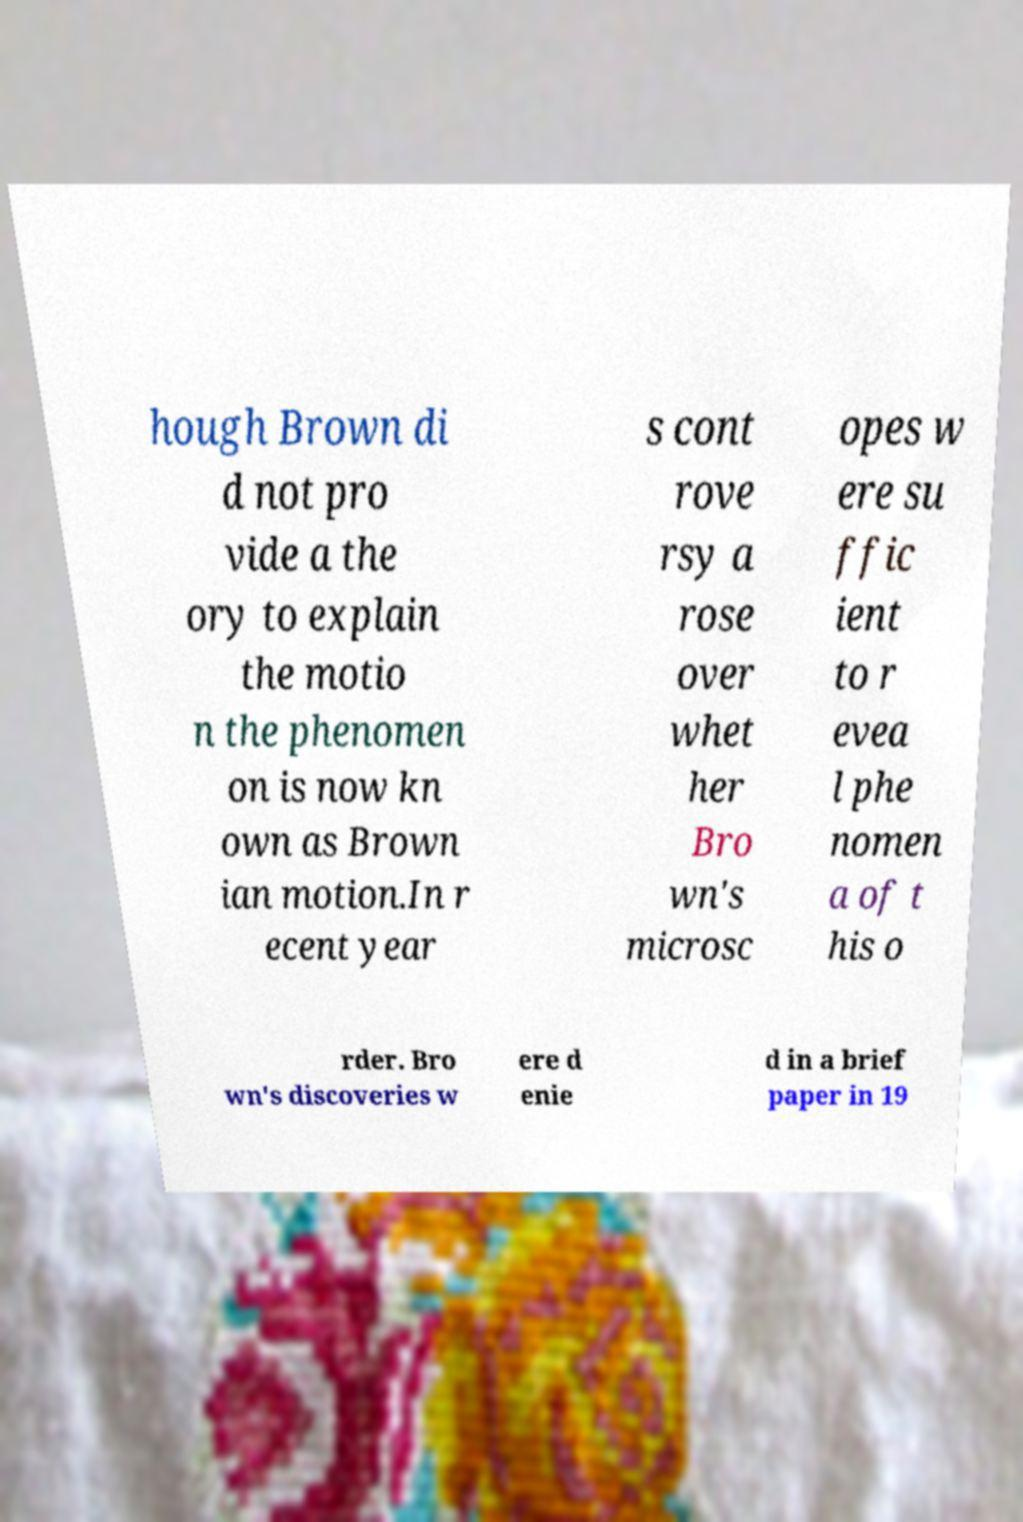What messages or text are displayed in this image? I need them in a readable, typed format. hough Brown di d not pro vide a the ory to explain the motio n the phenomen on is now kn own as Brown ian motion.In r ecent year s cont rove rsy a rose over whet her Bro wn's microsc opes w ere su ffic ient to r evea l phe nomen a of t his o rder. Bro wn's discoveries w ere d enie d in a brief paper in 19 